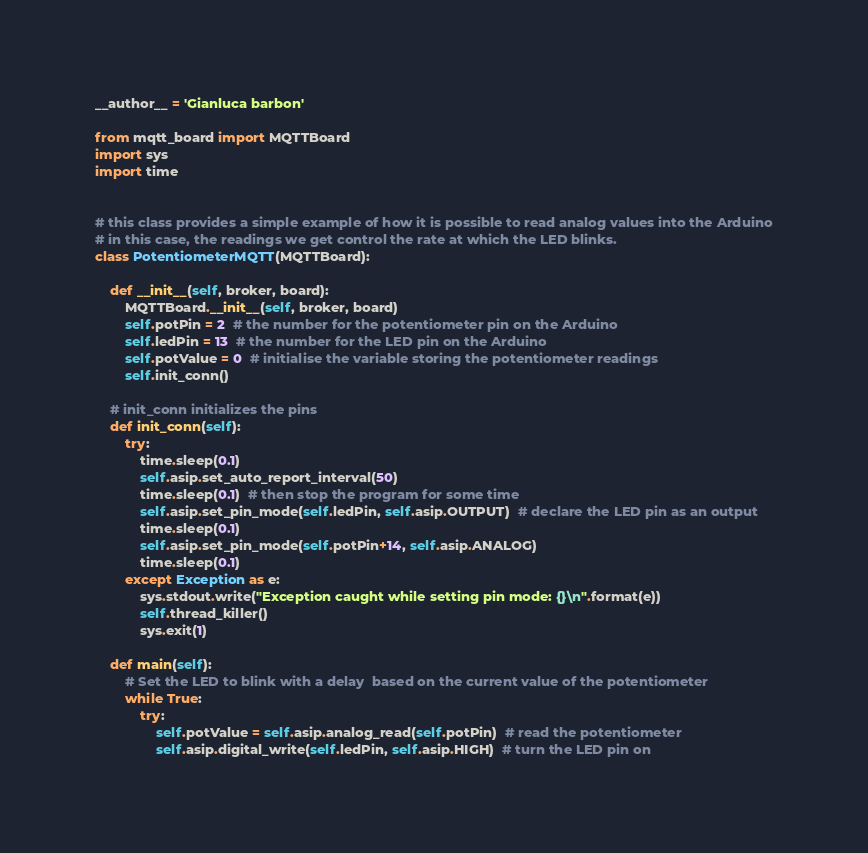Convert code to text. <code><loc_0><loc_0><loc_500><loc_500><_Python_>__author__ = 'Gianluca barbon'

from mqtt_board import MQTTBoard
import sys
import time


# this class provides a simple example of how it is possible to read analog values into the Arduino
# in this case, the readings we get control the rate at which the LED blinks.
class PotentiometerMQTT(MQTTBoard):

    def __init__(self, broker, board):
        MQTTBoard.__init__(self, broker, board)
        self.potPin = 2  # the number for the potentiometer pin on the Arduino
        self.ledPin = 13  # the number for the LED pin on the Arduino
        self.potValue = 0  # initialise the variable storing the potentiometer readings
        self.init_conn()

    # init_conn initializes the pins
    def init_conn(self):
        try:
            time.sleep(0.1)
            self.asip.set_auto_report_interval(50)
            time.sleep(0.1)  # then stop the program for some time
            self.asip.set_pin_mode(self.ledPin, self.asip.OUTPUT)  # declare the LED pin as an output
            time.sleep(0.1)
            self.asip.set_pin_mode(self.potPin+14, self.asip.ANALOG)
            time.sleep(0.1)
        except Exception as e:
            sys.stdout.write("Exception caught while setting pin mode: {}\n".format(e))
            self.thread_killer()
            sys.exit(1)

    def main(self):
        # Set the LED to blink with a delay  based on the current value of the potentiometer
        while True:
            try:
                self.potValue = self.asip.analog_read(self.potPin)  # read the potentiometer
                self.asip.digital_write(self.ledPin, self.asip.HIGH)  # turn the LED pin on</code> 